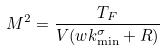Convert formula to latex. <formula><loc_0><loc_0><loc_500><loc_500>M ^ { 2 } = \frac { T _ { F } } { V ( w k _ { \min } ^ { \sigma } + R ) }</formula> 